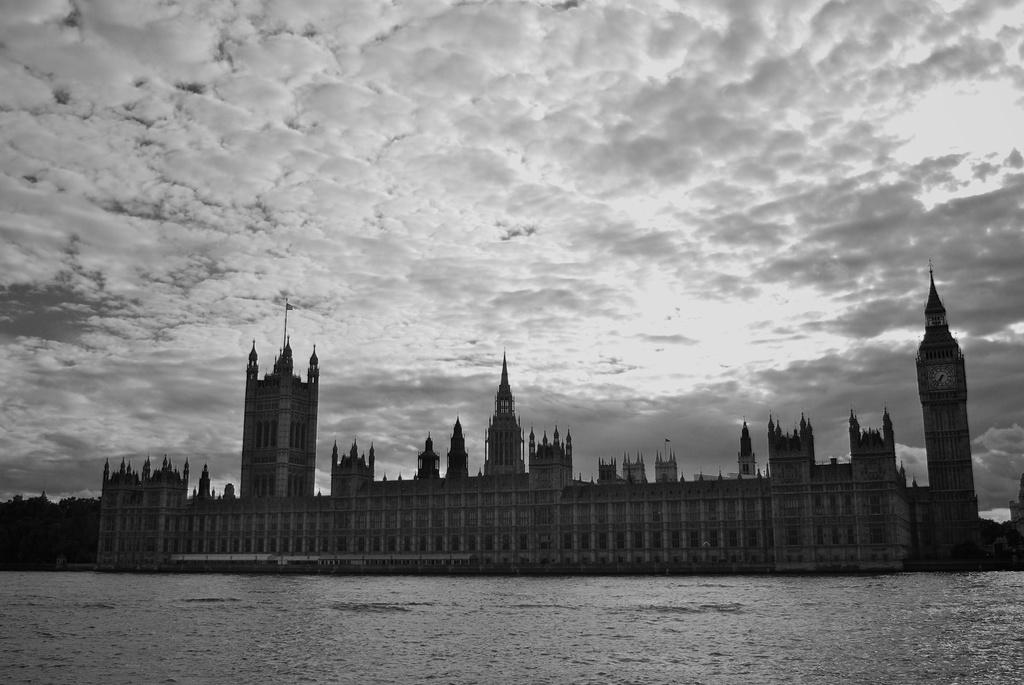What is the color scheme of the image? The image is black and white. What natural element can be seen in the image? There is water visible in the image. What type of structures are present in the image? There are buildings in the image. What type of vegetation is present in the image? There are trees in the image. What specific type of building can be seen in the image? There is a clock tower in the image. What is visible in the background of the image? The sky is visible in the background of the image. How many ants can be seen crawling on the clock tower in the image? There are no ants present in the image, so it is not possible to determine how many ants might be crawling on the clock tower. 